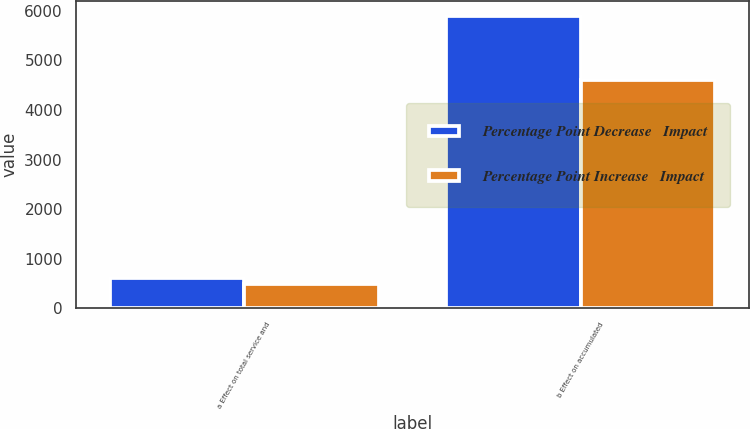Convert chart. <chart><loc_0><loc_0><loc_500><loc_500><stacked_bar_chart><ecel><fcel>a Effect on total service and<fcel>b Effect on accumulated<nl><fcel>Percentage Point Decrease   Impact<fcel>617<fcel>5905<nl><fcel>Percentage Point Increase   Impact<fcel>478<fcel>4611<nl></chart> 